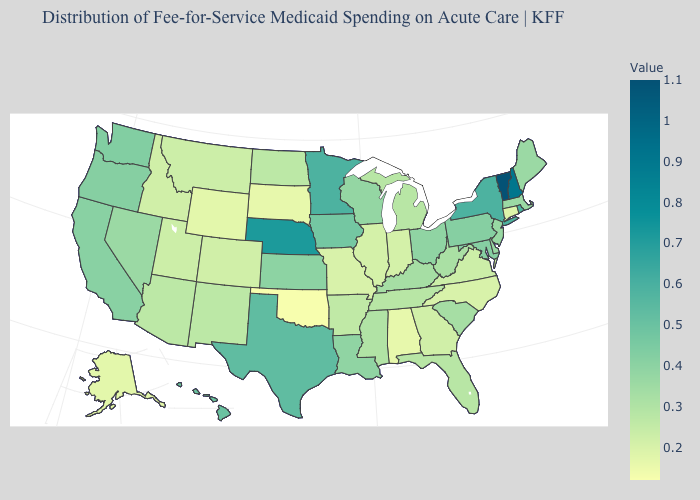Among the states that border Indiana , which have the highest value?
Be succinct. Ohio. Is the legend a continuous bar?
Be succinct. Yes. Which states hav the highest value in the West?
Short answer required. Hawaii. Which states hav the highest value in the MidWest?
Keep it brief. Nebraska. Does Connecticut have a lower value than Oregon?
Be succinct. Yes. Which states have the lowest value in the USA?
Answer briefly. Oklahoma. 